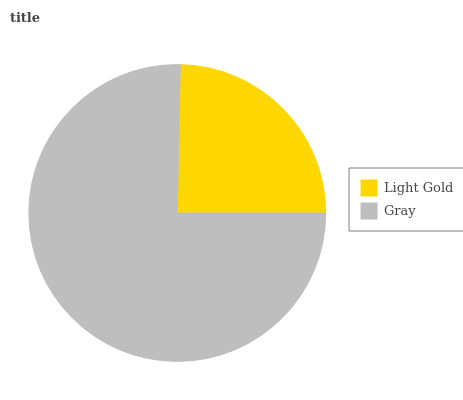Is Light Gold the minimum?
Answer yes or no. Yes. Is Gray the maximum?
Answer yes or no. Yes. Is Gray the minimum?
Answer yes or no. No. Is Gray greater than Light Gold?
Answer yes or no. Yes. Is Light Gold less than Gray?
Answer yes or no. Yes. Is Light Gold greater than Gray?
Answer yes or no. No. Is Gray less than Light Gold?
Answer yes or no. No. Is Gray the high median?
Answer yes or no. Yes. Is Light Gold the low median?
Answer yes or no. Yes. Is Light Gold the high median?
Answer yes or no. No. Is Gray the low median?
Answer yes or no. No. 